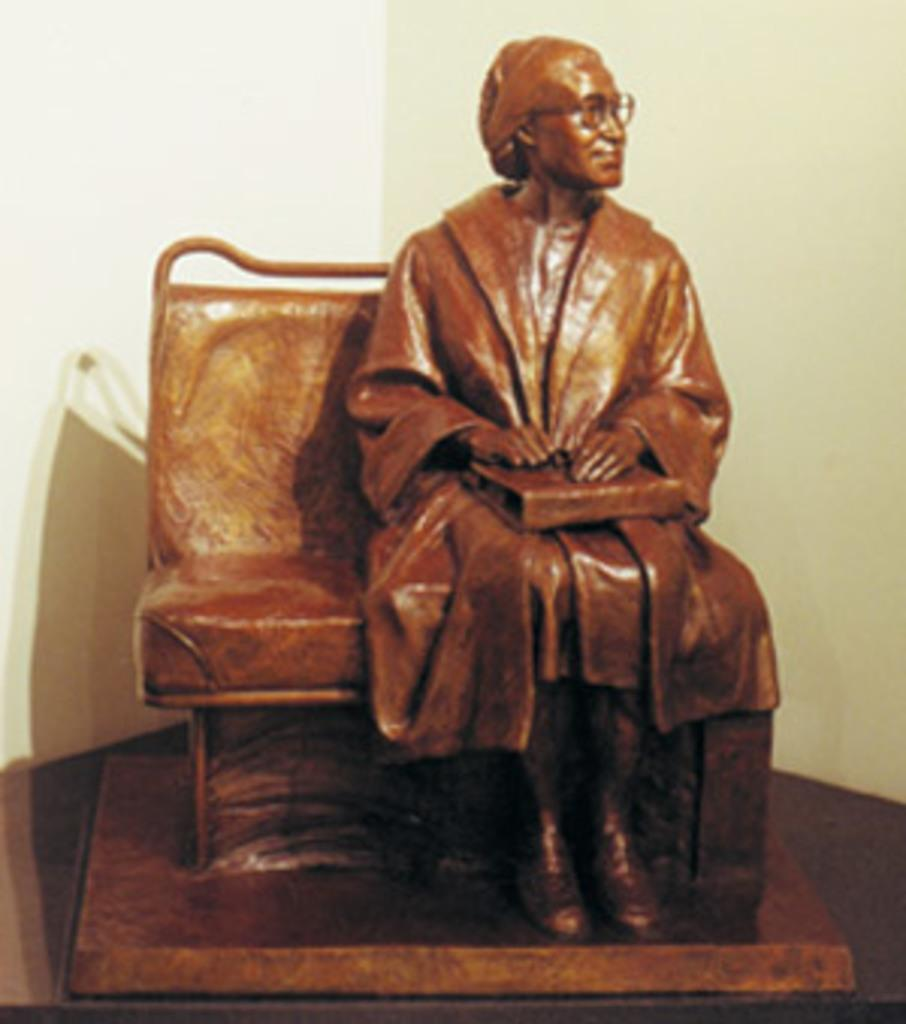What is the main subject of the image? There is a sculpture in the image. What is the sculpture depicting? The sculpture is of a person. What is the person in the sculpture holding? The person is holding a bag. What is the person in the sculpture doing? The person is sitting on a seat. What type of square can be seen in the image? There is no square present in the image. 